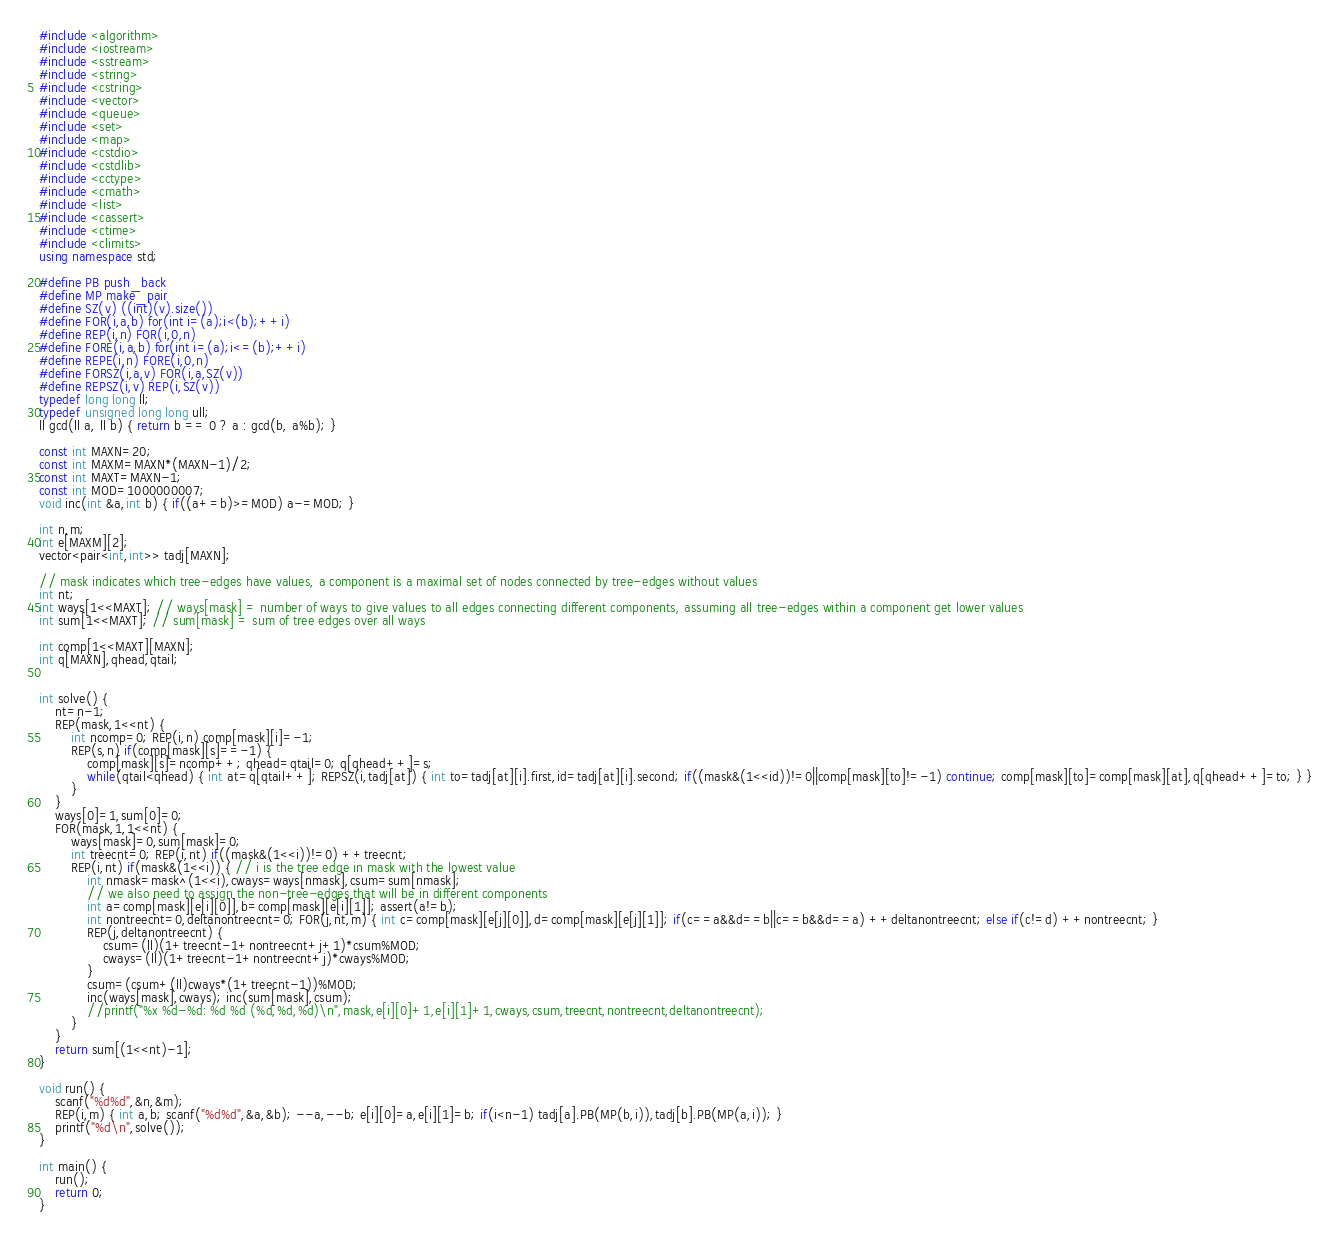Convert code to text. <code><loc_0><loc_0><loc_500><loc_500><_C++_>#include <algorithm>  
#include <iostream>  
#include <sstream>  
#include <string>  
#include <cstring>
#include <vector>  
#include <queue>  
#include <set>  
#include <map>  
#include <cstdio>  
#include <cstdlib>  
#include <cctype>  
#include <cmath>  
#include <list>  
#include <cassert>
#include <ctime>
#include <climits>
using namespace std;

#define PB push_back  
#define MP make_pair  
#define SZ(v) ((int)(v).size())  
#define FOR(i,a,b) for(int i=(a);i<(b);++i)  
#define REP(i,n) FOR(i,0,n)  
#define FORE(i,a,b) for(int i=(a);i<=(b);++i)  
#define REPE(i,n) FORE(i,0,n)  
#define FORSZ(i,a,v) FOR(i,a,SZ(v))  
#define REPSZ(i,v) REP(i,SZ(v))  
typedef long long ll;
typedef unsigned long long ull;
ll gcd(ll a, ll b) { return b == 0 ? a : gcd(b, a%b); }

const int MAXN=20;
const int MAXM=MAXN*(MAXN-1)/2;
const int MAXT=MAXN-1;
const int MOD=1000000007;
void inc(int &a,int b) { if((a+=b)>=MOD) a-=MOD; }

int n,m;
int e[MAXM][2];
vector<pair<int,int>> tadj[MAXN];

// mask indicates which tree-edges have values, a component is a maximal set of nodes connected by tree-edges without values
int nt;
int ways[1<<MAXT]; // ways[mask] = number of ways to give values to all edges connecting different components, assuming all tree-edges within a component get lower values
int sum[1<<MAXT]; // sum[mask] = sum of tree edges over all ways

int comp[1<<MAXT][MAXN];
int q[MAXN],qhead,qtail;


int solve() {
	nt=n-1;
	REP(mask,1<<nt) {
		int ncomp=0; REP(i,n) comp[mask][i]=-1;
		REP(s,n) if(comp[mask][s]==-1) {
			comp[mask][s]=ncomp++; qhead=qtail=0; q[qhead++]=s;
			while(qtail<qhead) { int at=q[qtail++]; REPSZ(i,tadj[at]) { int to=tadj[at][i].first,id=tadj[at][i].second; if((mask&(1<<id))!=0||comp[mask][to]!=-1) continue; comp[mask][to]=comp[mask][at],q[qhead++]=to; } }
		}
	}
	ways[0]=1,sum[0]=0;
	FOR(mask,1,1<<nt) {
		ways[mask]=0,sum[mask]=0;
		int treecnt=0; REP(i,nt) if((mask&(1<<i))!=0) ++treecnt;
		REP(i,nt) if(mask&(1<<i)) { // i is the tree edge in mask with the lowest value
			int nmask=mask^(1<<i),cways=ways[nmask],csum=sum[nmask];
			// we also need to assign the non-tree-edges that will be in different components
			int a=comp[mask][e[i][0]],b=comp[mask][e[i][1]]; assert(a!=b);
			int nontreecnt=0,deltanontreecnt=0; FOR(j,nt,m) { int c=comp[mask][e[j][0]],d=comp[mask][e[j][1]]; if(c==a&&d==b||c==b&&d==a) ++deltanontreecnt; else if(c!=d) ++nontreecnt; }
			REP(j,deltanontreecnt) {
				csum=(ll)(1+treecnt-1+nontreecnt+j+1)*csum%MOD;
				cways=(ll)(1+treecnt-1+nontreecnt+j)*cways%MOD;
			}
			csum=(csum+(ll)cways*(1+treecnt-1))%MOD;
			inc(ways[mask],cways); inc(sum[mask],csum);
			//printf("%x %d-%d: %d %d (%d,%d,%d)\n",mask,e[i][0]+1,e[i][1]+1,cways,csum,treecnt,nontreecnt,deltanontreecnt);
		}
	}
	return sum[(1<<nt)-1];
}

void run() {
	scanf("%d%d",&n,&m);
	REP(i,m) { int a,b; scanf("%d%d",&a,&b); --a,--b; e[i][0]=a,e[i][1]=b; if(i<n-1) tadj[a].PB(MP(b,i)),tadj[b].PB(MP(a,i)); }
	printf("%d\n",solve());
}

int main() {
	run();
	return 0;
}</code> 